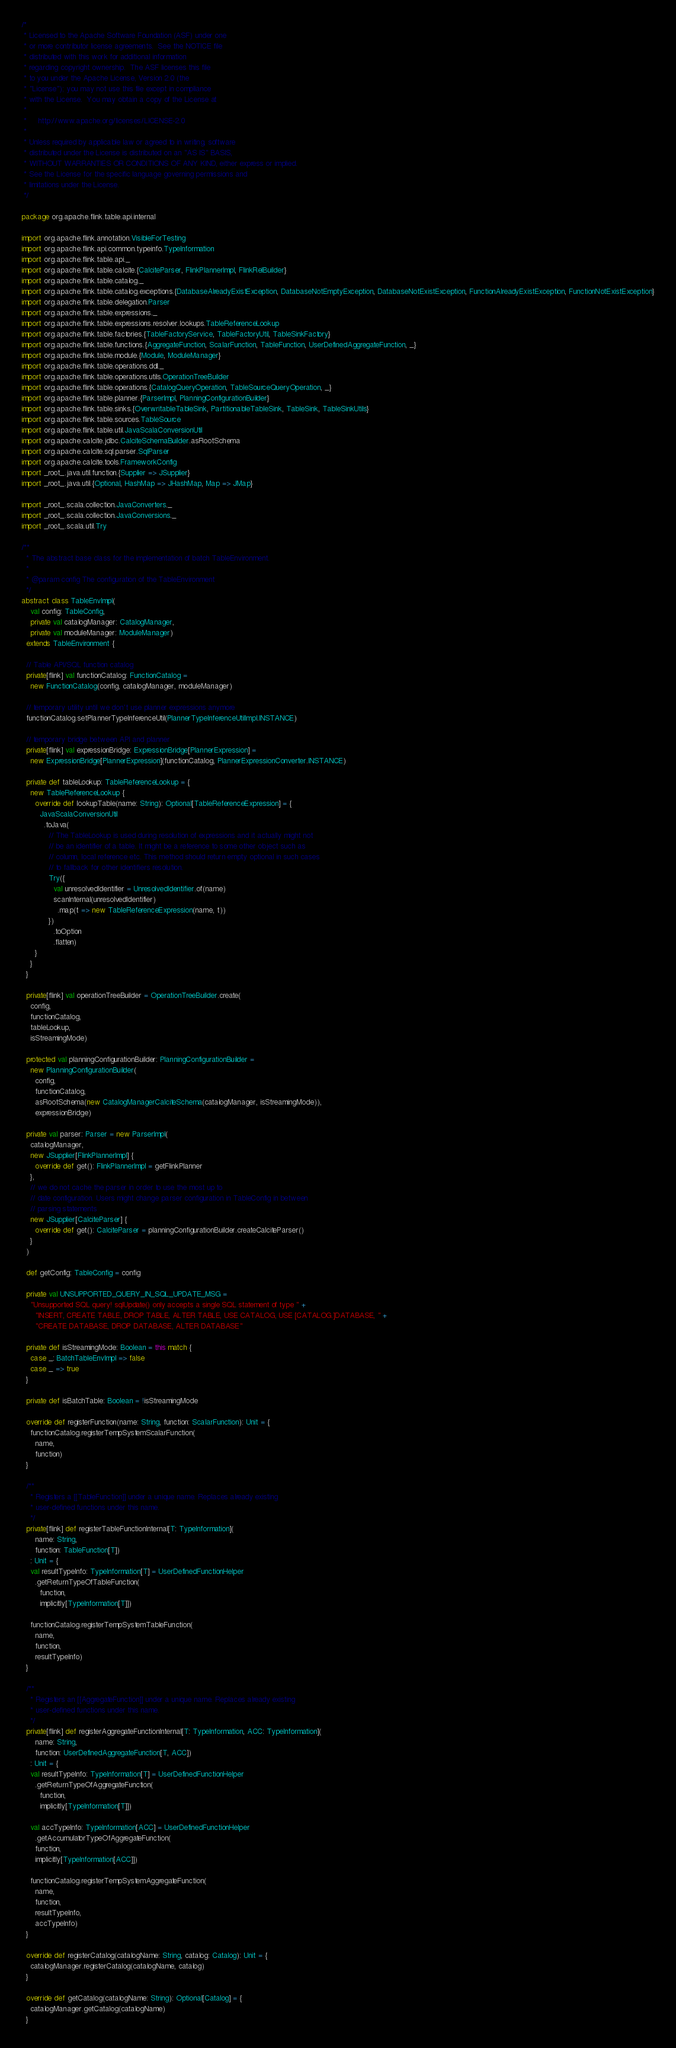<code> <loc_0><loc_0><loc_500><loc_500><_Scala_>/*
 * Licensed to the Apache Software Foundation (ASF) under one
 * or more contributor license agreements.  See the NOTICE file
 * distributed with this work for additional information
 * regarding copyright ownership.  The ASF licenses this file
 * to you under the Apache License, Version 2.0 (the
 * "License"); you may not use this file except in compliance
 * with the License.  You may obtain a copy of the License at
 *
 *     http://www.apache.org/licenses/LICENSE-2.0
 *
 * Unless required by applicable law or agreed to in writing, software
 * distributed under the License is distributed on an "AS IS" BASIS,
 * WITHOUT WARRANTIES OR CONDITIONS OF ANY KIND, either express or implied.
 * See the License for the specific language governing permissions and
 * limitations under the License.
 */

package org.apache.flink.table.api.internal

import org.apache.flink.annotation.VisibleForTesting
import org.apache.flink.api.common.typeinfo.TypeInformation
import org.apache.flink.table.api._
import org.apache.flink.table.calcite.{CalciteParser, FlinkPlannerImpl, FlinkRelBuilder}
import org.apache.flink.table.catalog._
import org.apache.flink.table.catalog.exceptions.{DatabaseAlreadyExistException, DatabaseNotEmptyException, DatabaseNotExistException, FunctionAlreadyExistException, FunctionNotExistException}
import org.apache.flink.table.delegation.Parser
import org.apache.flink.table.expressions._
import org.apache.flink.table.expressions.resolver.lookups.TableReferenceLookup
import org.apache.flink.table.factories.{TableFactoryService, TableFactoryUtil, TableSinkFactory}
import org.apache.flink.table.functions.{AggregateFunction, ScalarFunction, TableFunction, UserDefinedAggregateFunction, _}
import org.apache.flink.table.module.{Module, ModuleManager}
import org.apache.flink.table.operations.ddl._
import org.apache.flink.table.operations.utils.OperationTreeBuilder
import org.apache.flink.table.operations.{CatalogQueryOperation, TableSourceQueryOperation, _}
import org.apache.flink.table.planner.{ParserImpl, PlanningConfigurationBuilder}
import org.apache.flink.table.sinks.{OverwritableTableSink, PartitionableTableSink, TableSink, TableSinkUtils}
import org.apache.flink.table.sources.TableSource
import org.apache.flink.table.util.JavaScalaConversionUtil
import org.apache.calcite.jdbc.CalciteSchemaBuilder.asRootSchema
import org.apache.calcite.sql.parser.SqlParser
import org.apache.calcite.tools.FrameworkConfig
import _root_.java.util.function.{Supplier => JSupplier}
import _root_.java.util.{Optional, HashMap => JHashMap, Map => JMap}

import _root_.scala.collection.JavaConverters._
import _root_.scala.collection.JavaConversions._
import _root_.scala.util.Try

/**
  * The abstract base class for the implementation of batch TableEnvironment.
  *
  * @param config The configuration of the TableEnvironment
  */
abstract class TableEnvImpl(
    val config: TableConfig,
    private val catalogManager: CatalogManager,
    private val moduleManager: ModuleManager)
  extends TableEnvironment {

  // Table API/SQL function catalog
  private[flink] val functionCatalog: FunctionCatalog =
    new FunctionCatalog(config, catalogManager, moduleManager)

  // temporary utility until we don't use planner expressions anymore
  functionCatalog.setPlannerTypeInferenceUtil(PlannerTypeInferenceUtilImpl.INSTANCE)

  // temporary bridge between API and planner
  private[flink] val expressionBridge: ExpressionBridge[PlannerExpression] =
    new ExpressionBridge[PlannerExpression](functionCatalog, PlannerExpressionConverter.INSTANCE)

  private def tableLookup: TableReferenceLookup = {
    new TableReferenceLookup {
      override def lookupTable(name: String): Optional[TableReferenceExpression] = {
        JavaScalaConversionUtil
          .toJava(
            // The TableLookup is used during resolution of expressions and it actually might not
            // be an identifier of a table. It might be a reference to some other object such as
            // column, local reference etc. This method should return empty optional in such cases
            // to fallback for other identifiers resolution.
            Try({
              val unresolvedIdentifier = UnresolvedIdentifier.of(name)
              scanInternal(unresolvedIdentifier)
                .map(t => new TableReferenceExpression(name, t))
            })
              .toOption
              .flatten)
      }
    }
  }

  private[flink] val operationTreeBuilder = OperationTreeBuilder.create(
    config,
    functionCatalog,
    tableLookup,
    isStreamingMode)

  protected val planningConfigurationBuilder: PlanningConfigurationBuilder =
    new PlanningConfigurationBuilder(
      config,
      functionCatalog,
      asRootSchema(new CatalogManagerCalciteSchema(catalogManager, isStreamingMode)),
      expressionBridge)

  private val parser: Parser = new ParserImpl(
    catalogManager,
    new JSupplier[FlinkPlannerImpl] {
      override def get(): FlinkPlannerImpl = getFlinkPlanner
    },
    // we do not cache the parser in order to use the most up to
    // date configuration. Users might change parser configuration in TableConfig in between
    // parsing statements
    new JSupplier[CalciteParser] {
      override def get(): CalciteParser = planningConfigurationBuilder.createCalciteParser()
    }
  )

  def getConfig: TableConfig = config

  private val UNSUPPORTED_QUERY_IN_SQL_UPDATE_MSG =
    "Unsupported SQL query! sqlUpdate() only accepts a single SQL statement of type " +
      "INSERT, CREATE TABLE, DROP TABLE, ALTER TABLE, USE CATALOG, USE [CATALOG.]DATABASE, " +
      "CREATE DATABASE, DROP DATABASE, ALTER DATABASE"

  private def isStreamingMode: Boolean = this match {
    case _: BatchTableEnvImpl => false
    case _ => true
  }

  private def isBatchTable: Boolean = !isStreamingMode

  override def registerFunction(name: String, function: ScalarFunction): Unit = {
    functionCatalog.registerTempSystemScalarFunction(
      name,
      function)
  }

  /**
    * Registers a [[TableFunction]] under a unique name. Replaces already existing
    * user-defined functions under this name.
    */
  private[flink] def registerTableFunctionInternal[T: TypeInformation](
      name: String,
      function: TableFunction[T])
    : Unit = {
    val resultTypeInfo: TypeInformation[T] = UserDefinedFunctionHelper
      .getReturnTypeOfTableFunction(
        function,
        implicitly[TypeInformation[T]])

    functionCatalog.registerTempSystemTableFunction(
      name,
      function,
      resultTypeInfo)
  }

  /**
    * Registers an [[AggregateFunction]] under a unique name. Replaces already existing
    * user-defined functions under this name.
    */
  private[flink] def registerAggregateFunctionInternal[T: TypeInformation, ACC: TypeInformation](
      name: String,
      function: UserDefinedAggregateFunction[T, ACC])
    : Unit = {
    val resultTypeInfo: TypeInformation[T] = UserDefinedFunctionHelper
      .getReturnTypeOfAggregateFunction(
        function,
        implicitly[TypeInformation[T]])

    val accTypeInfo: TypeInformation[ACC] = UserDefinedFunctionHelper
      .getAccumulatorTypeOfAggregateFunction(
      function,
      implicitly[TypeInformation[ACC]])

    functionCatalog.registerTempSystemAggregateFunction(
      name,
      function,
      resultTypeInfo,
      accTypeInfo)
  }

  override def registerCatalog(catalogName: String, catalog: Catalog): Unit = {
    catalogManager.registerCatalog(catalogName, catalog)
  }

  override def getCatalog(catalogName: String): Optional[Catalog] = {
    catalogManager.getCatalog(catalogName)
  }
</code> 